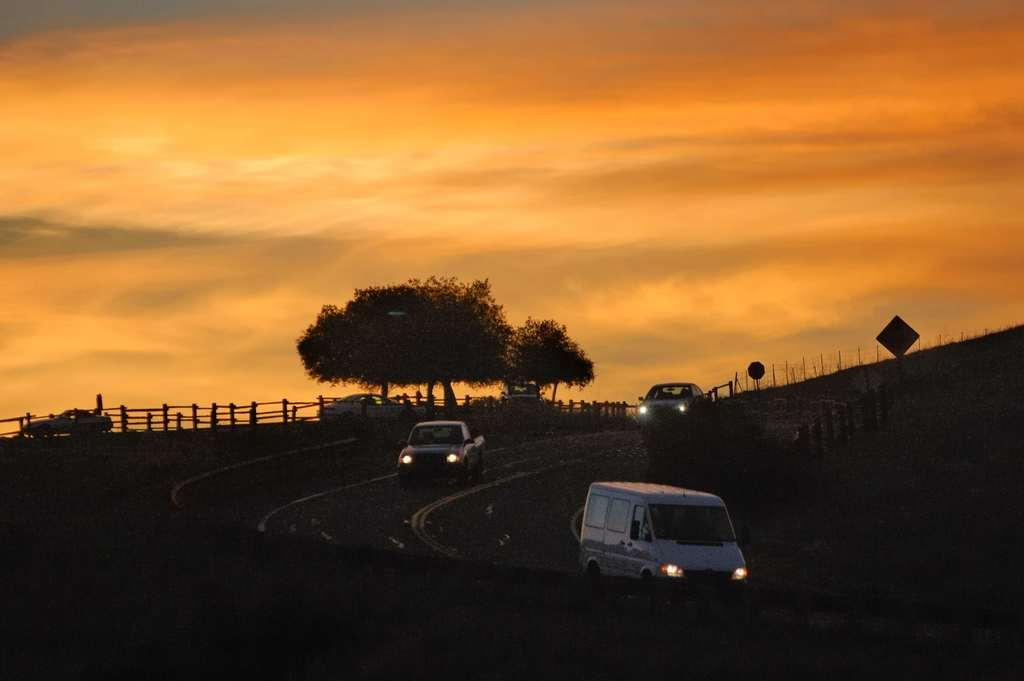What can be seen on the road in the image? There are vehicles on the road in the image. What type of barrier is present in the image? There is a fence in the image. What type of vegetation is visible in the image? There are trees in the image. What type of structures can be seen in the image? There are poles in the image. What is visible in the sky in the image? Clouds are visible in the sky in the image. What type of jam is being spread on the quilt in the image? There is no jam or quilt present in the image. How many kittens are playing with the poles in the image? There are no kittens present in the image. 